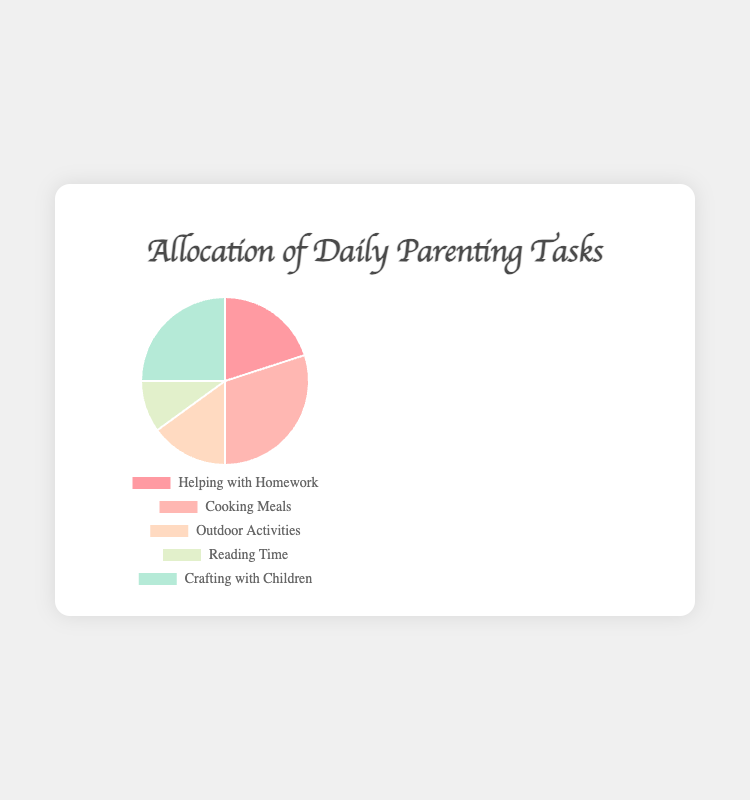What's the largest slice in the pie chart? The largest slice is identified by looking for the task with the highest time allocation. "Cooking Meals" has 90 minutes.
Answer: Cooking Meals How many more minutes are spent on "Crafting with Children" compared to "Outdoor Activities"? "Crafting with Children" has 75 minutes and "Outdoor Activities" has 45 minutes, so the difference is 75 - 45.
Answer: 30 Which task takes up the smallest portion of the pie chart? The task with the lowest time allocation is the smallest portion. "Reading Time" has 30 minutes.
Answer: Reading Time What's the combined time spent on "Helping with Homework" and "Outdoor Activities"? Add the time for "Helping with Homework" (60 minutes) and "Outdoor Activities" (45 minutes). 60 + 45
Answer: 105 Is more time spent on "Crafting with Children" or "Helping with Homework"? Compare the minutes: "Crafting with Children" (75) and "Helping with Homework" (60).
Answer: Crafting with Children What is the percentage of time spent on "Cooking Meals" relative to the total daily time allocated? Total time is 300 minutes. (Cooking Meals = 90 minutes). Percentage = (90/300) * 100%.
Answer: 30% Arrange the tasks from the most to the least time spent. Order the tasks by time: Cooking Meals (90), Crafting with Children (75), Helping with Homework (60), Outdoor Activities (45), Reading Time (30).
Answer: Cooking Meals, Crafting with Children, Helping with Homework, Outdoor Activities, Reading Time What's the ratio of time spent on "Outdoor Activities" to "Reading Time"? Divide the time for "Outdoor Activities" (45) by the time for "Reading Time" (30). 45/30 = 3:2.
Answer: 3:2 What percentage of the total time is dedicated to "Helping with Homework"? Total time is 300 minutes. (Helping with Homework = 60 minutes). Percentage = (60/300) * 100%.
Answer: 20% Which time allocation is visually represented by a greenish color in the pie chart? Identify the greenish color section which corresponds to "Crafting with Children".
Answer: Crafting with Children 